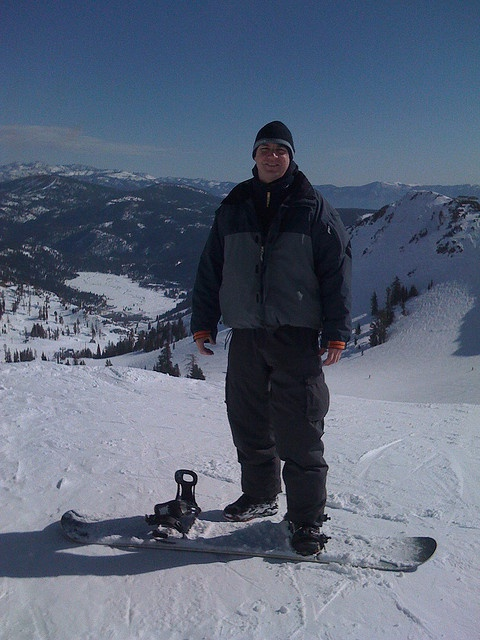Describe the objects in this image and their specific colors. I can see people in navy, black, gray, and maroon tones and snowboard in navy, darkgray, black, and gray tones in this image. 